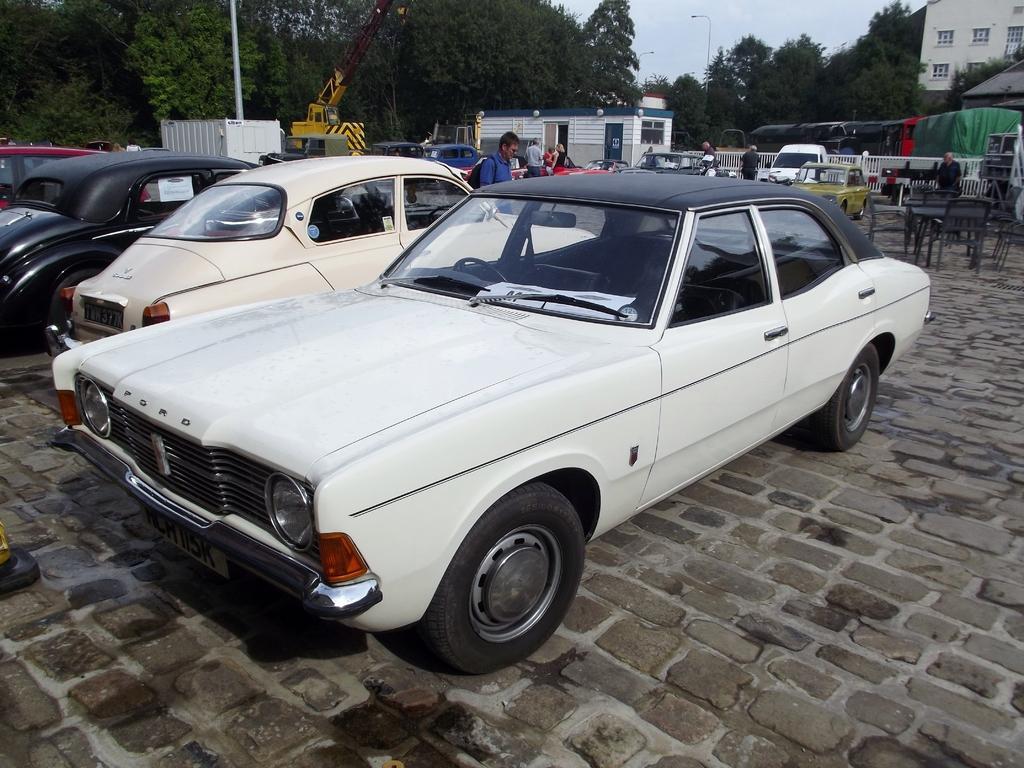How would you summarize this image in a sentence or two? In this image there are few vehicles, persons, tables, chairs, trees, street lights, a building, a pole attached the box and the sky. 